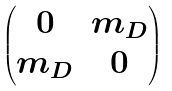<formula> <loc_0><loc_0><loc_500><loc_500>\begin{pmatrix} 0 & m _ { D } \\ m _ { D } & 0 \end{pmatrix}</formula> 